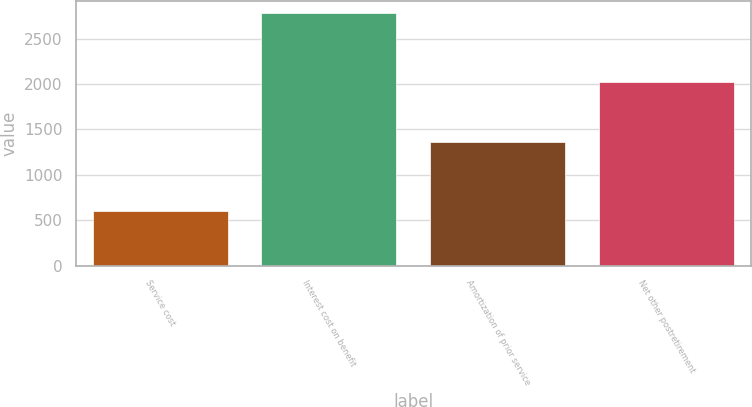<chart> <loc_0><loc_0><loc_500><loc_500><bar_chart><fcel>Service cost<fcel>Interest cost on benefit<fcel>Amortization of prior service<fcel>Net other postretirement<nl><fcel>605<fcel>2778<fcel>1359<fcel>2024<nl></chart> 